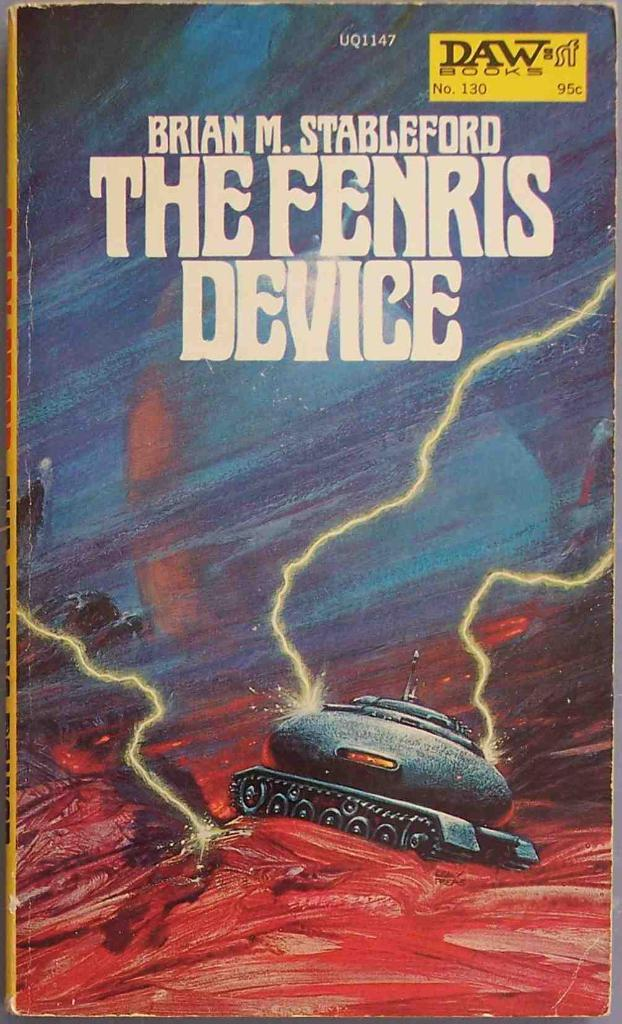<image>
Relay a brief, clear account of the picture shown. a book that is called The Fenris Device with red and blue on it 